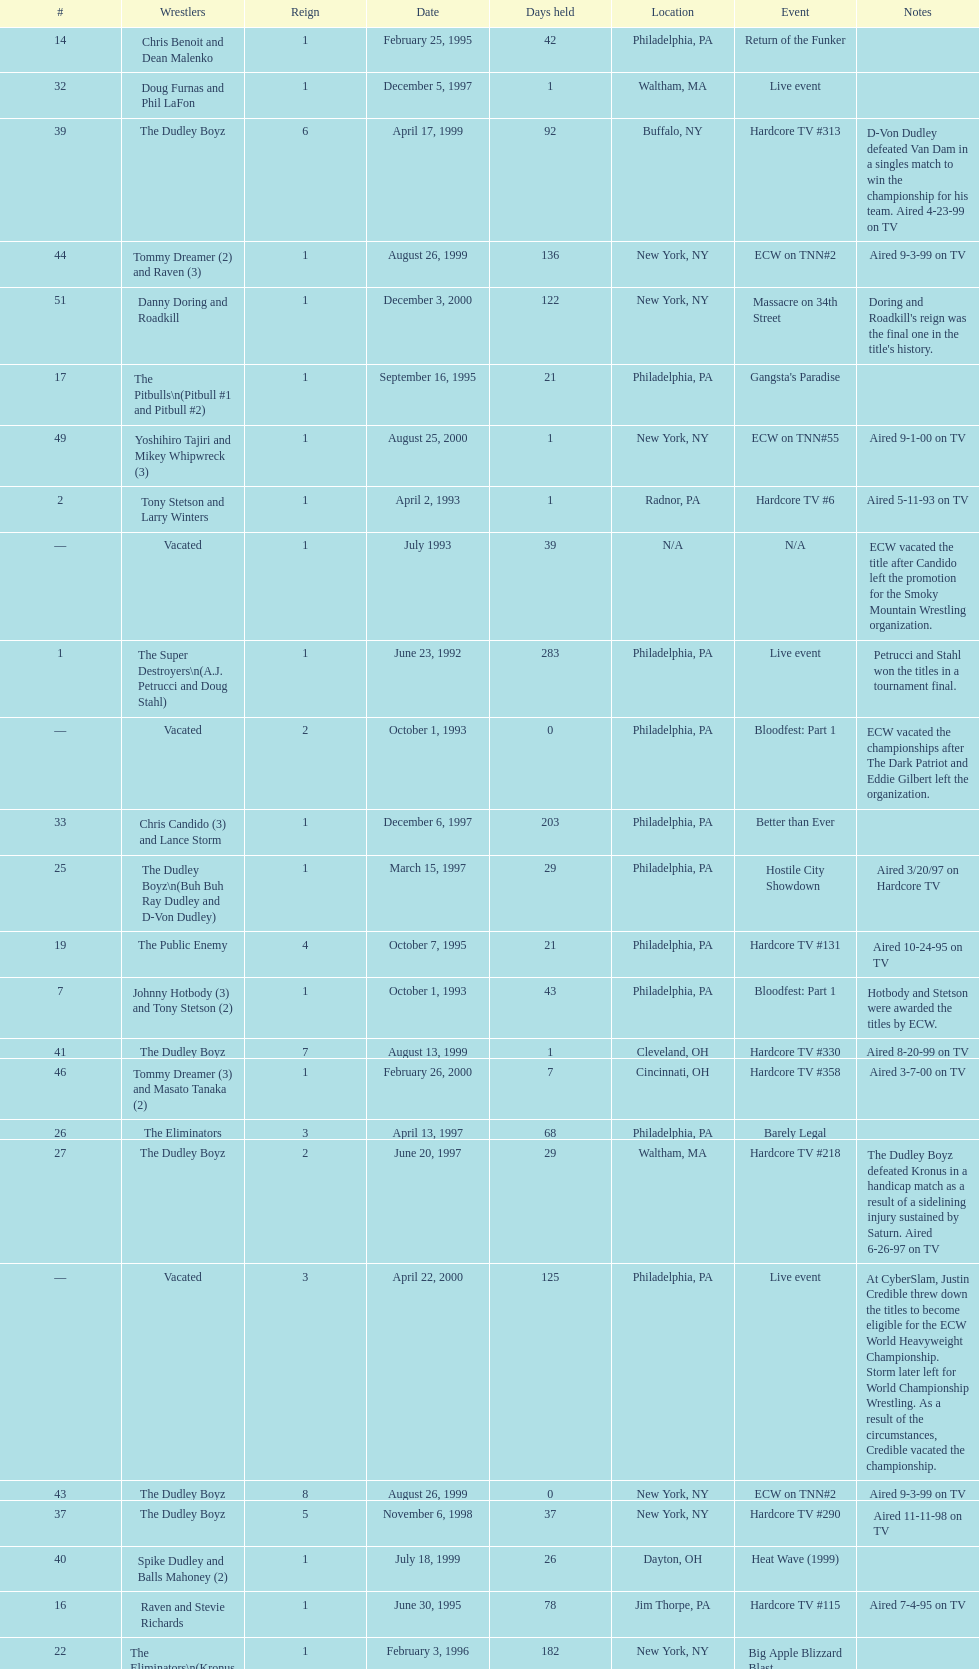What event comes before hardcore tv #14? Hardcore TV #8. 